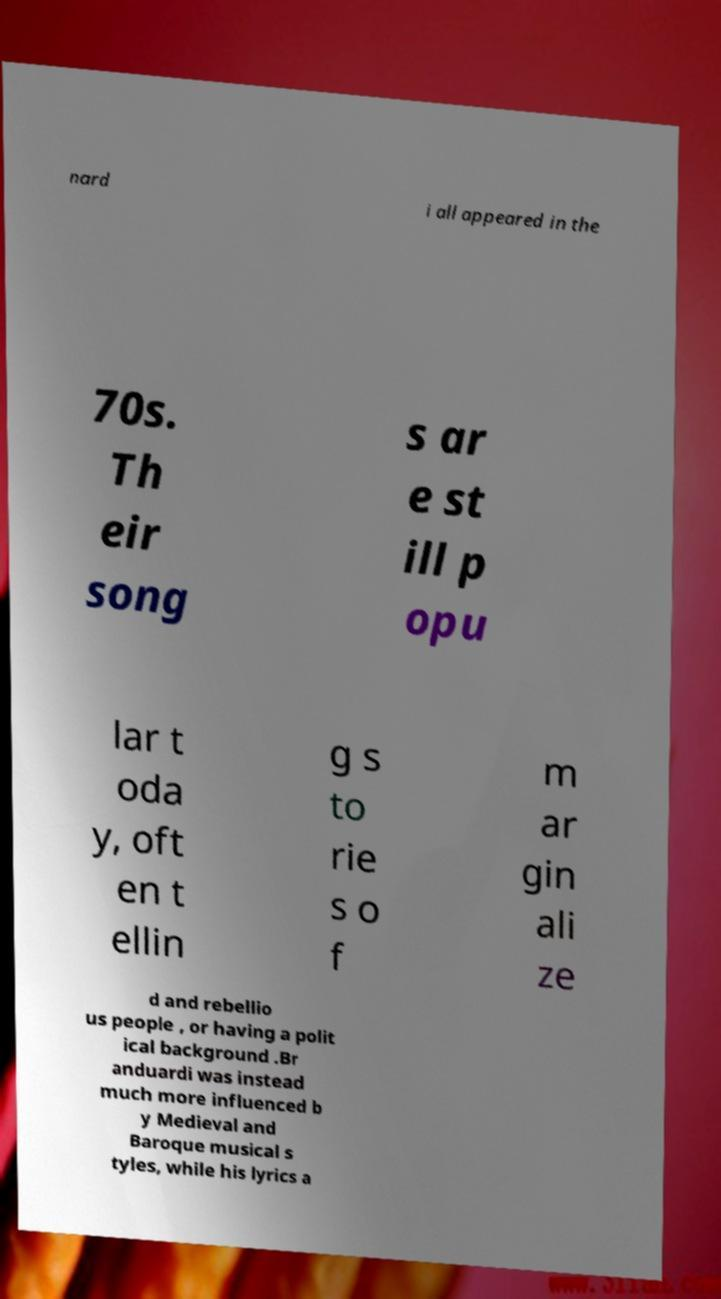There's text embedded in this image that I need extracted. Can you transcribe it verbatim? nard i all appeared in the 70s. Th eir song s ar e st ill p opu lar t oda y, oft en t ellin g s to rie s o f m ar gin ali ze d and rebellio us people , or having a polit ical background .Br anduardi was instead much more influenced b y Medieval and Baroque musical s tyles, while his lyrics a 